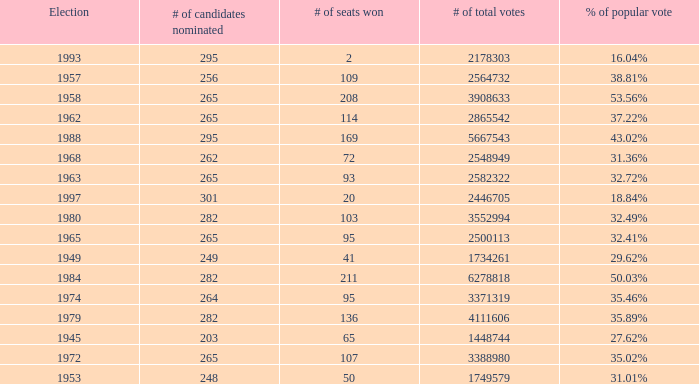What year was the election when the # of seats won was 65? 1945.0. Could you parse the entire table as a dict? {'header': ['Election', '# of candidates nominated', '# of seats won', '# of total votes', '% of popular vote'], 'rows': [['1993', '295', '2', '2178303', '16.04%'], ['1957', '256', '109', '2564732', '38.81%'], ['1958', '265', '208', '3908633', '53.56%'], ['1962', '265', '114', '2865542', '37.22%'], ['1988', '295', '169', '5667543', '43.02%'], ['1968', '262', '72', '2548949', '31.36%'], ['1963', '265', '93', '2582322', '32.72%'], ['1997', '301', '20', '2446705', '18.84%'], ['1980', '282', '103', '3552994', '32.49%'], ['1965', '265', '95', '2500113', '32.41%'], ['1949', '249', '41', '1734261', '29.62%'], ['1984', '282', '211', '6278818', '50.03%'], ['1974', '264', '95', '3371319', '35.46%'], ['1979', '282', '136', '4111606', '35.89%'], ['1945', '203', '65', '1448744', '27.62%'], ['1972', '265', '107', '3388980', '35.02%'], ['1953', '248', '50', '1749579', '31.01%']]} 